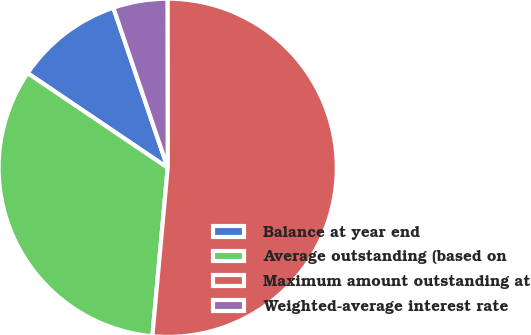<chart> <loc_0><loc_0><loc_500><loc_500><pie_chart><fcel>Balance at year end<fcel>Average outstanding (based on<fcel>Maximum amount outstanding at<fcel>Weighted-average interest rate<nl><fcel>10.33%<fcel>33.01%<fcel>51.46%<fcel>5.19%<nl></chart> 